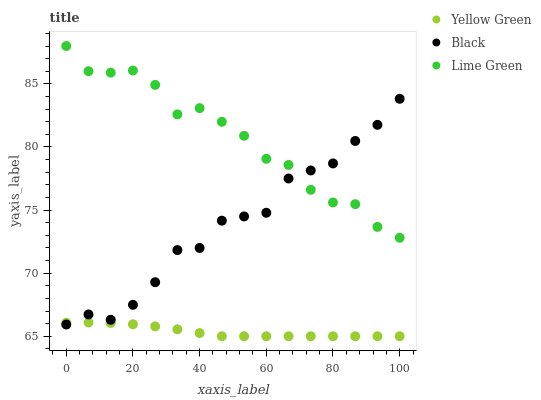Does Yellow Green have the minimum area under the curve?
Answer yes or no. Yes. Does Lime Green have the maximum area under the curve?
Answer yes or no. Yes. Does Black have the minimum area under the curve?
Answer yes or no. No. Does Black have the maximum area under the curve?
Answer yes or no. No. Is Yellow Green the smoothest?
Answer yes or no. Yes. Is Black the roughest?
Answer yes or no. Yes. Is Black the smoothest?
Answer yes or no. No. Is Yellow Green the roughest?
Answer yes or no. No. Does Yellow Green have the lowest value?
Answer yes or no. Yes. Does Black have the lowest value?
Answer yes or no. No. Does Lime Green have the highest value?
Answer yes or no. Yes. Does Black have the highest value?
Answer yes or no. No. Is Yellow Green less than Lime Green?
Answer yes or no. Yes. Is Lime Green greater than Yellow Green?
Answer yes or no. Yes. Does Yellow Green intersect Black?
Answer yes or no. Yes. Is Yellow Green less than Black?
Answer yes or no. No. Is Yellow Green greater than Black?
Answer yes or no. No. Does Yellow Green intersect Lime Green?
Answer yes or no. No. 